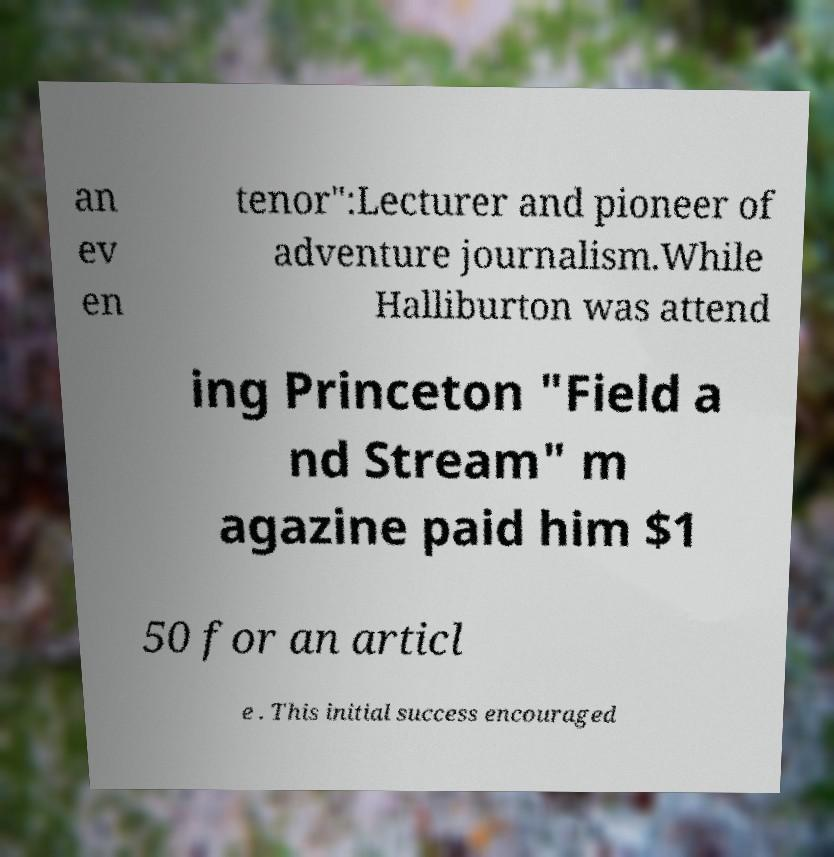I need the written content from this picture converted into text. Can you do that? an ev en tenor":Lecturer and pioneer of adventure journalism.While Halliburton was attend ing Princeton "Field a nd Stream" m agazine paid him $1 50 for an articl e . This initial success encouraged 